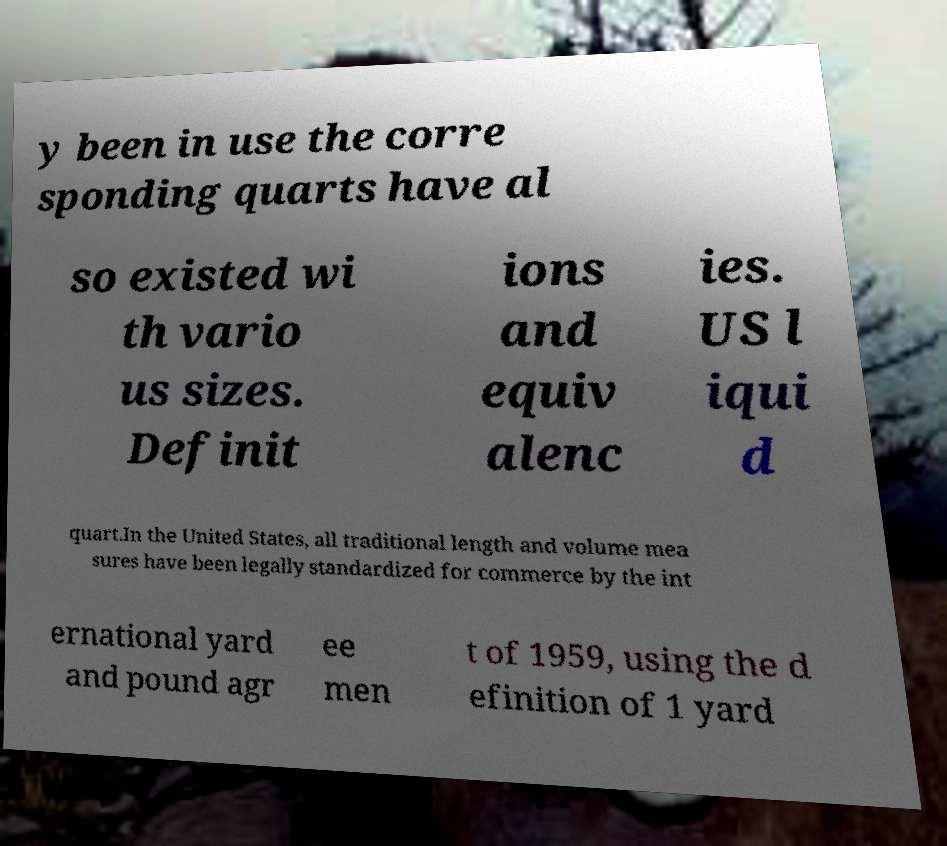There's text embedded in this image that I need extracted. Can you transcribe it verbatim? y been in use the corre sponding quarts have al so existed wi th vario us sizes. Definit ions and equiv alenc ies. US l iqui d quart.In the United States, all traditional length and volume mea sures have been legally standardized for commerce by the int ernational yard and pound agr ee men t of 1959, using the d efinition of 1 yard 